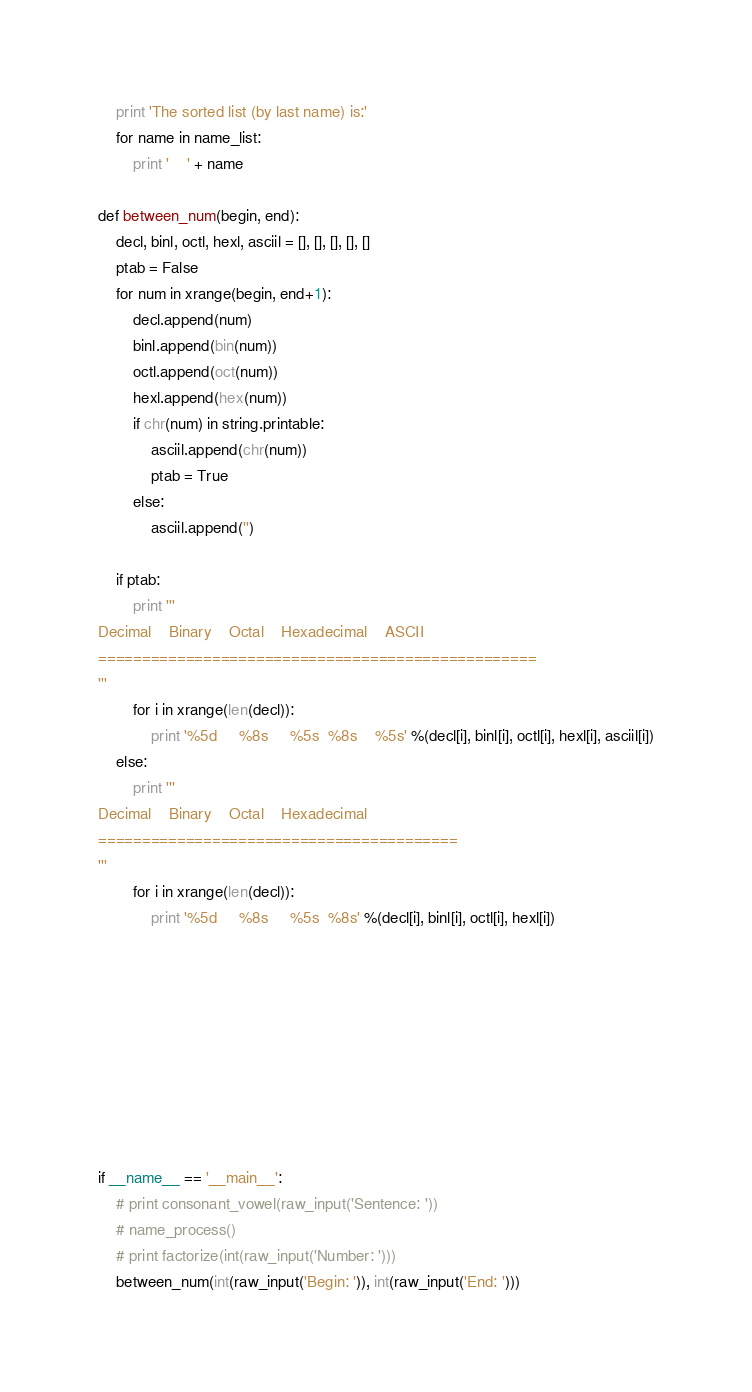<code> <loc_0><loc_0><loc_500><loc_500><_Python_>    print 'The sorted list (by last name) is:'
    for name in name_list:
        print '    ' + name

def between_num(begin, end):
    decl, binl, octl, hexl, asciil = [], [], [], [], []
    ptab = False
    for num in xrange(begin, end+1):
        decl.append(num)
        binl.append(bin(num))
        octl.append(oct(num))
        hexl.append(hex(num))
        if chr(num) in string.printable:
            asciil.append(chr(num))
            ptab = True
        else:
            asciil.append('')

    if ptab:
        print '''
Decimal    Binary    Octal    Hexadecimal    ASCII
==================================================
'''
        for i in xrange(len(decl)):
            print '%5d     %8s     %5s  %8s    %5s' %(decl[i], binl[i], octl[i], hexl[i], asciil[i])
    else:
        print '''
Decimal    Binary    Octal    Hexadecimal
=========================================
'''
        for i in xrange(len(decl)):
            print '%5d     %8s     %5s  %8s' %(decl[i], binl[i], octl[i], hexl[i])









if __name__ == '__main__':
    # print consonant_vowel(raw_input('Sentence: '))
    # name_process()
    # print factorize(int(raw_input('Number: ')))
    between_num(int(raw_input('Begin: ')), int(raw_input('End: ')))

</code> 